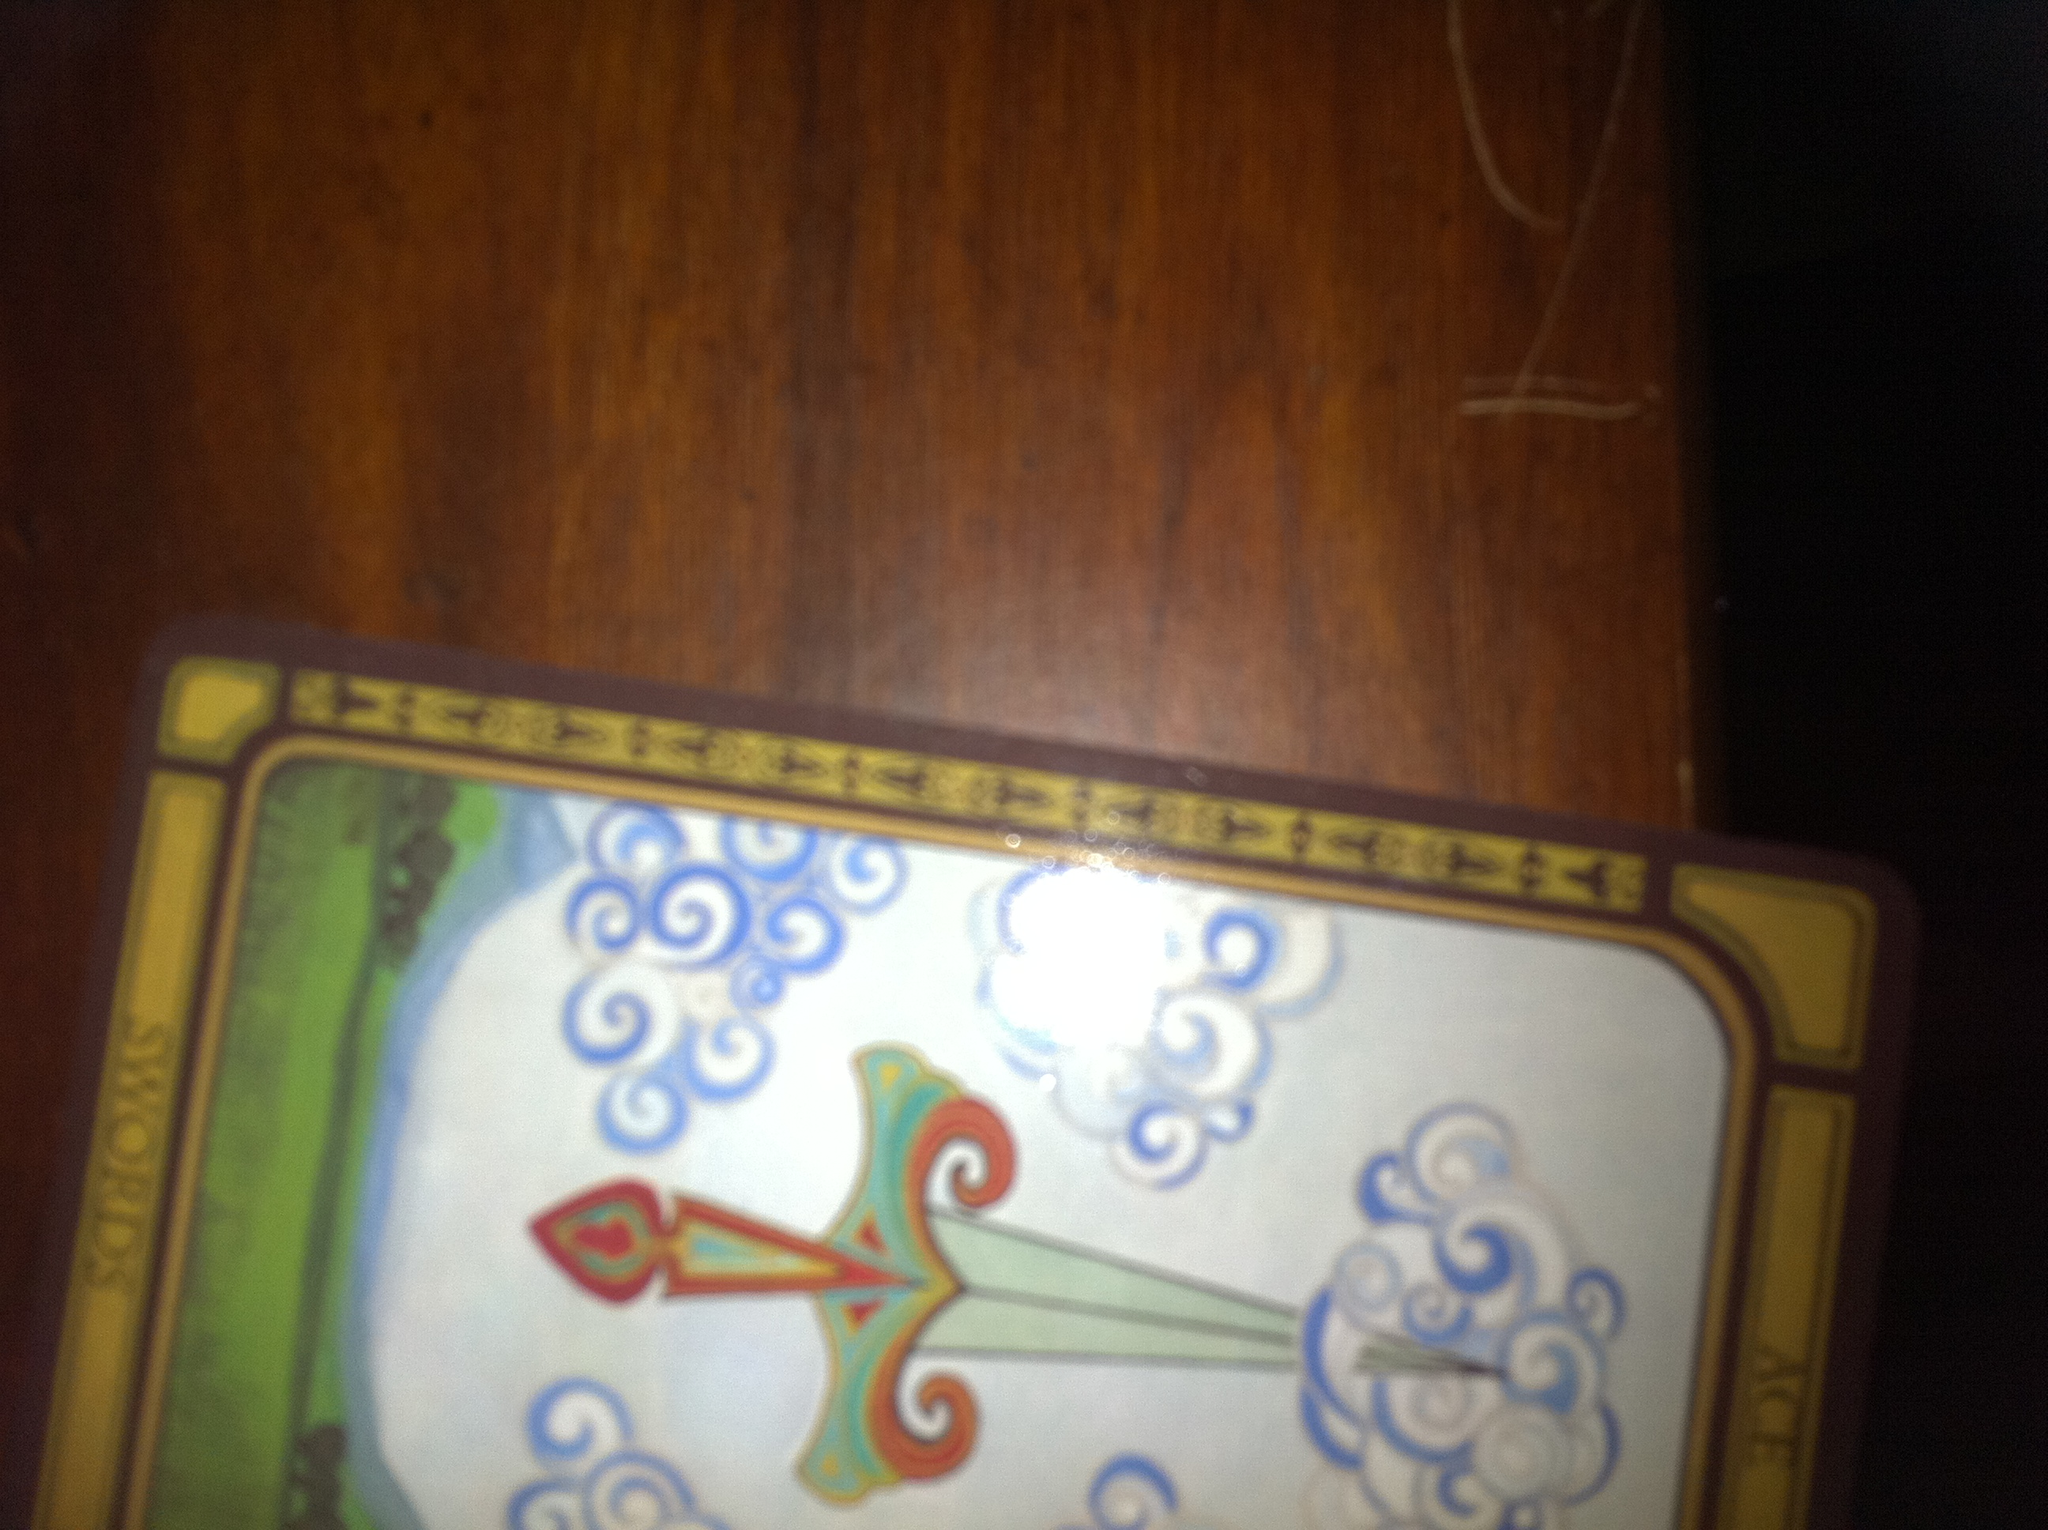As a realistic scenario, how would drawing the Ace of Swords influence a person's decisions? Drawing the Ace of Swords in a reading could influence a person to approach their decisions with a clear, logical mindset. It might encourage them to think critically and be decisive, using their intellect to overcome challenges and make well-informed choices. 